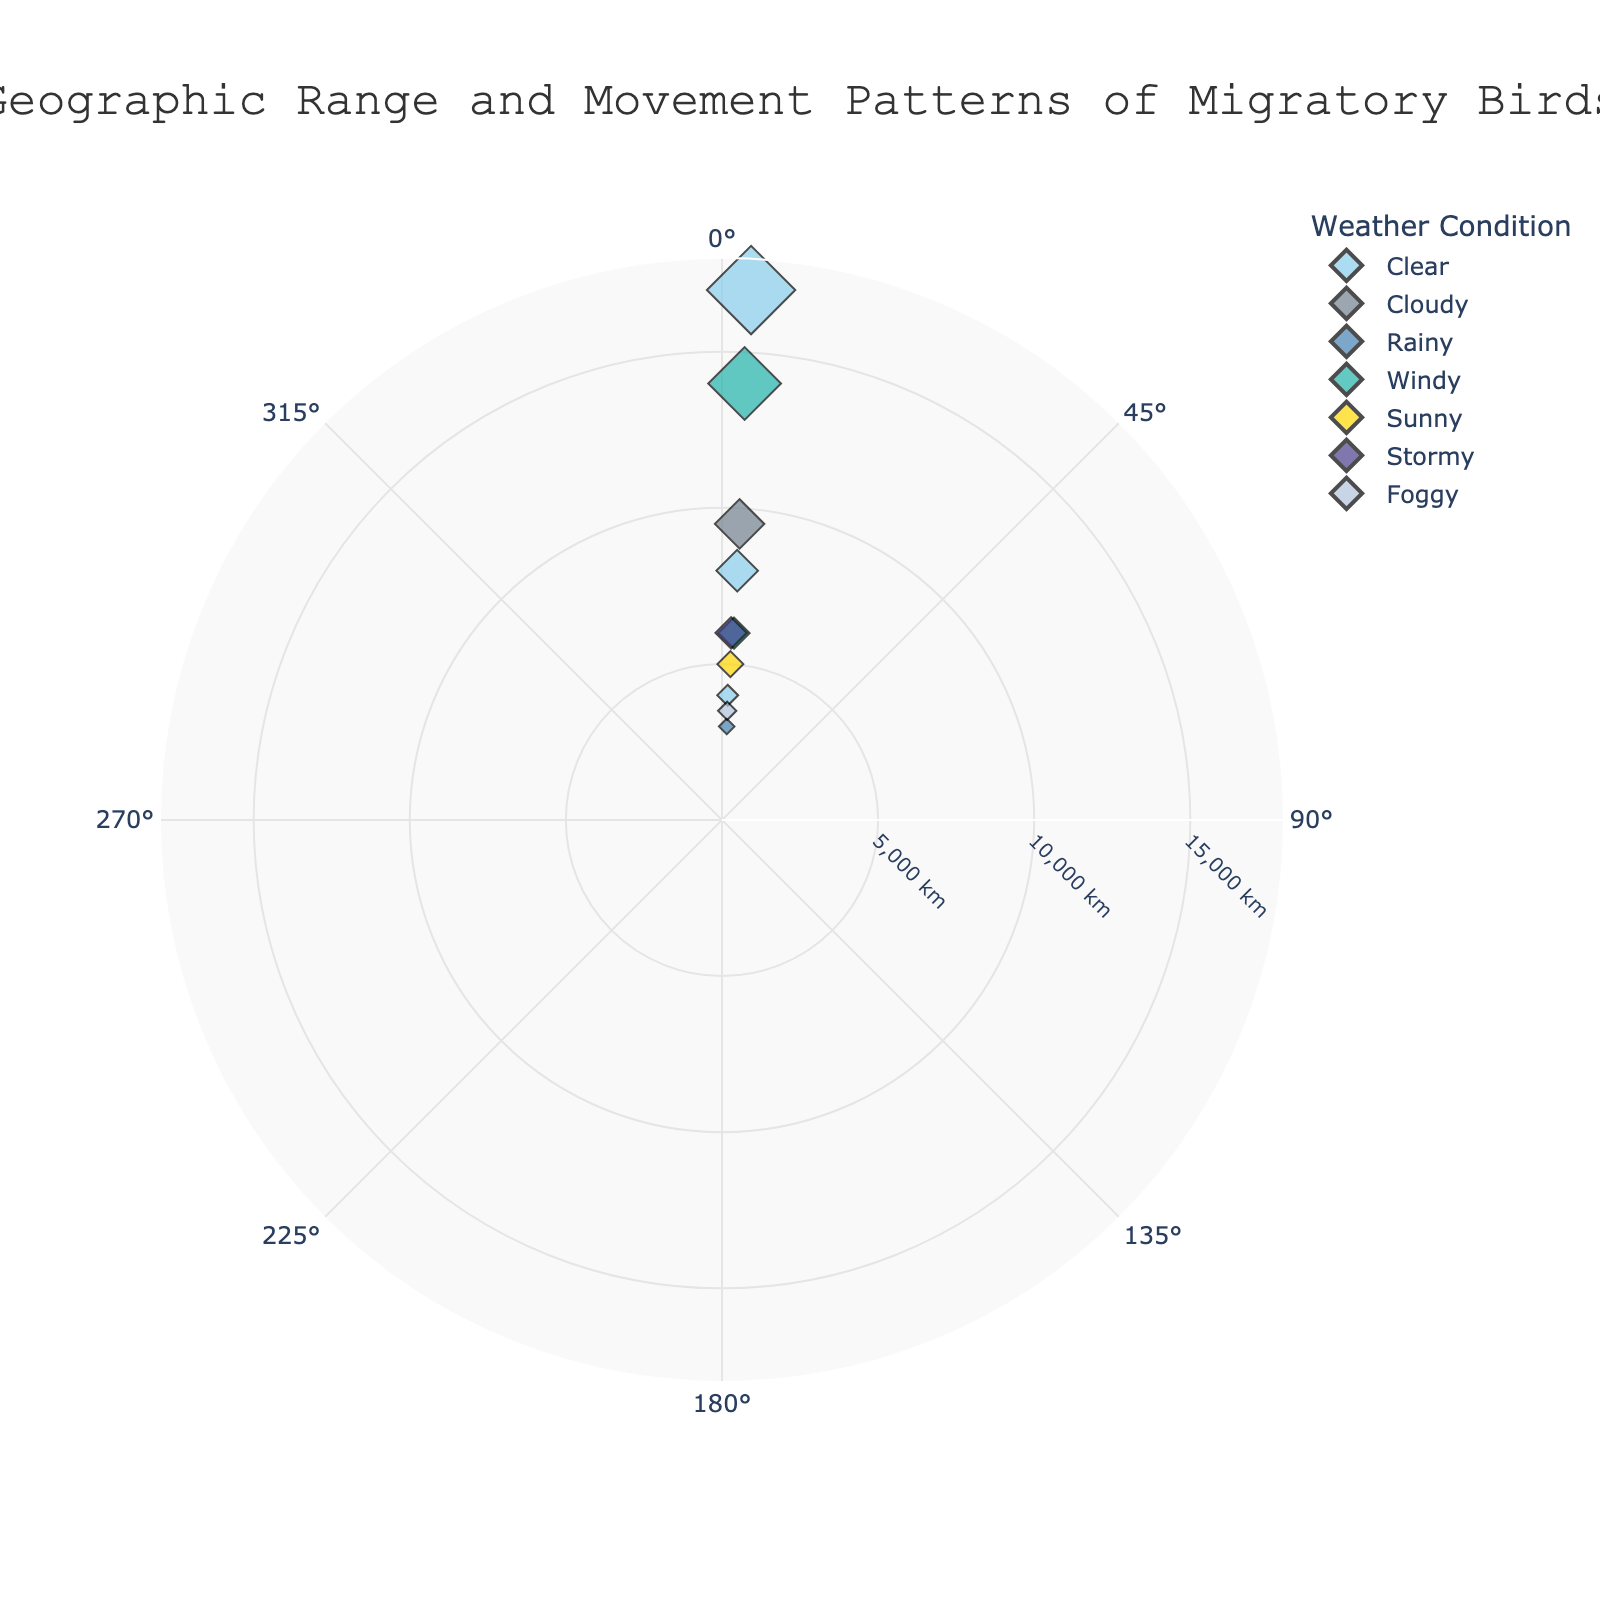What is the title of the polar scatter chart? The title is located at the top of the chart and provides an overview of the data being presented.
Answer: Geographic Range and Movement Patterns of Migratory Birds How many different weather conditions are represented in the chart? The legend on the chart lists the different weather conditions, each represented by a different color.
Answer: 7 Which bird species has the longest migration distance and what is the distance? The Arctic Tern data point is the farthest from the center, corresponding to the highest radial value.
Answer: Arctic Tern, 17000 km What weather condition is associated with the longest bird migration? By identifying the Arctic Tern's data point and matching its color with the legend, we see that it corresponds to Clear weather.
Answer: Clear Which bird migrates in the direction closest to south (180 degrees)? By examining bird species around the 180-degree mark, we identify the data point closest to 180 degrees.
Answer: Arctic Tern Which two bird species have the same migration distance, and what is that distance? Look for two data points at the same radial distance and different angular positions. The two species at the same radial distance (6000 km) are Blackpoll Warbler and Common Swift.
Answer: 6000 km Which bird species has the shortest migration distance and what is this distance? The Snow Goose has the shortest migration distance, located nearest to the center of the chart.
Answer: Snow Goose, 3000 km What is the average migration distance of birds migrating in Clear weather? First, identify data points with Clear weather, sum their distances, then divide by the number of points: (Arctic Tern 17000 + American Robin 4000 + Northern Wheatear 8000) / 3
Answer: 9667 km How does the migration direction of the Red Knot compare to that of the Sandhill Crane? Locate both data points and compare their angular positions. The Red Knot is at 170 degrees, and the Sandhill Crane is at 175 degrees.
Answer: Red Knot is 5 degrees less Which bird species migrates through the most severe weather condition (Stormy), and what is the distance? Identify the data point corresponding to Stormy weather and read the radial value.
Answer: Blackpoll Warbler, 6000 km 